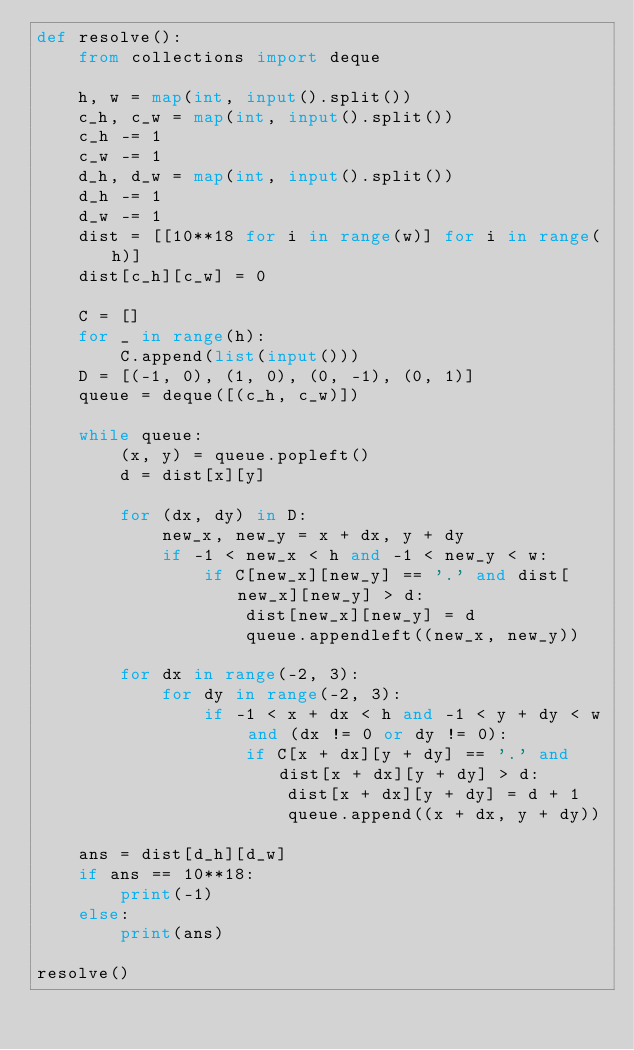<code> <loc_0><loc_0><loc_500><loc_500><_Python_>def resolve():
    from collections import deque

    h, w = map(int, input().split())
    c_h, c_w = map(int, input().split())
    c_h -= 1
    c_w -= 1
    d_h, d_w = map(int, input().split())
    d_h -= 1
    d_w -= 1
    dist = [[10**18 for i in range(w)] for i in range(h)]
    dist[c_h][c_w] = 0

    C = []
    for _ in range(h):
        C.append(list(input()))
    D = [(-1, 0), (1, 0), (0, -1), (0, 1)]
    queue = deque([(c_h, c_w)])

    while queue:
        (x, y) = queue.popleft()
        d = dist[x][y]

        for (dx, dy) in D:
            new_x, new_y = x + dx, y + dy
            if -1 < new_x < h and -1 < new_y < w:
                if C[new_x][new_y] == '.' and dist[new_x][new_y] > d:
                    dist[new_x][new_y] = d
                    queue.appendleft((new_x, new_y))

        for dx in range(-2, 3):
            for dy in range(-2, 3):
                if -1 < x + dx < h and -1 < y + dy < w and (dx != 0 or dy != 0):
                    if C[x + dx][y + dy] == '.' and dist[x + dx][y + dy] > d:
                        dist[x + dx][y + dy] = d + 1
                        queue.append((x + dx, y + dy))

    ans = dist[d_h][d_w]
    if ans == 10**18:
        print(-1)
    else:
        print(ans)

resolve()</code> 